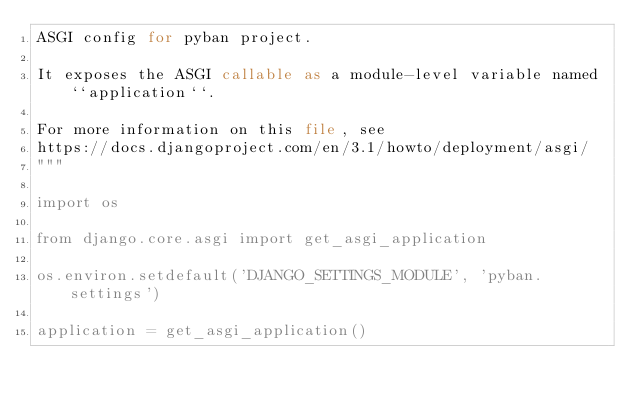<code> <loc_0><loc_0><loc_500><loc_500><_Python_>ASGI config for pyban project.

It exposes the ASGI callable as a module-level variable named ``application``.

For more information on this file, see
https://docs.djangoproject.com/en/3.1/howto/deployment/asgi/
"""

import os

from django.core.asgi import get_asgi_application

os.environ.setdefault('DJANGO_SETTINGS_MODULE', 'pyban.settings')

application = get_asgi_application()
</code> 